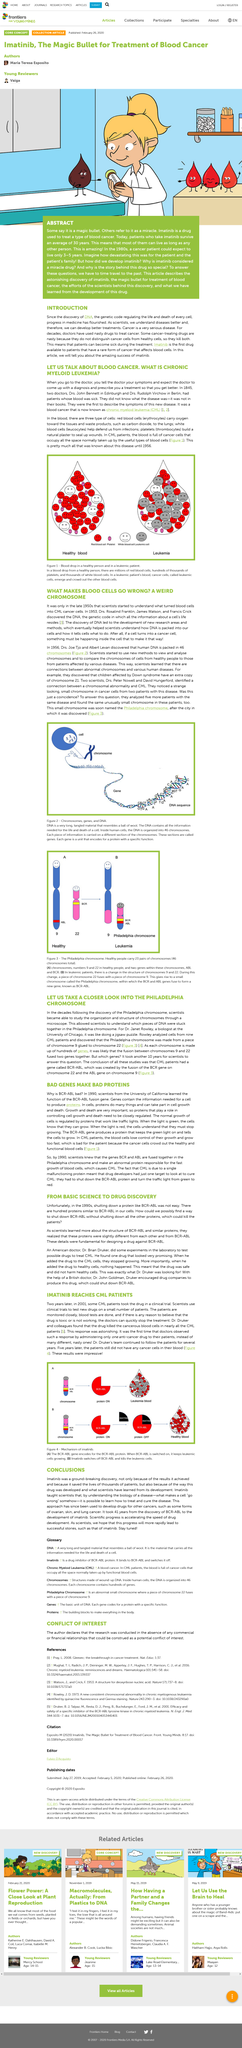Point out several critical features in this image. Drs. Joe Tjo and Albert Levan discovered that human DNA is packed into 46 chromosomes. CML, also known as Chronic Myeloid Leukemia, is caused by the abnormal fusion of the genes BCR and ABL, which results in the production of an abnormal protein that promotes the rapid growth of blood cells. By 1990, scientists had identified the Philadelphia chromosome as the source of this fusion and its causal role in CML. It is a well-established fact that there are three types of cells present in normal blood. The results of a clinical trial of the drug Imatinib showed that it was effective in switching off and killing leukemic cells. Proteins in cells perform various functions and play a crucial role in cell growth and death. 